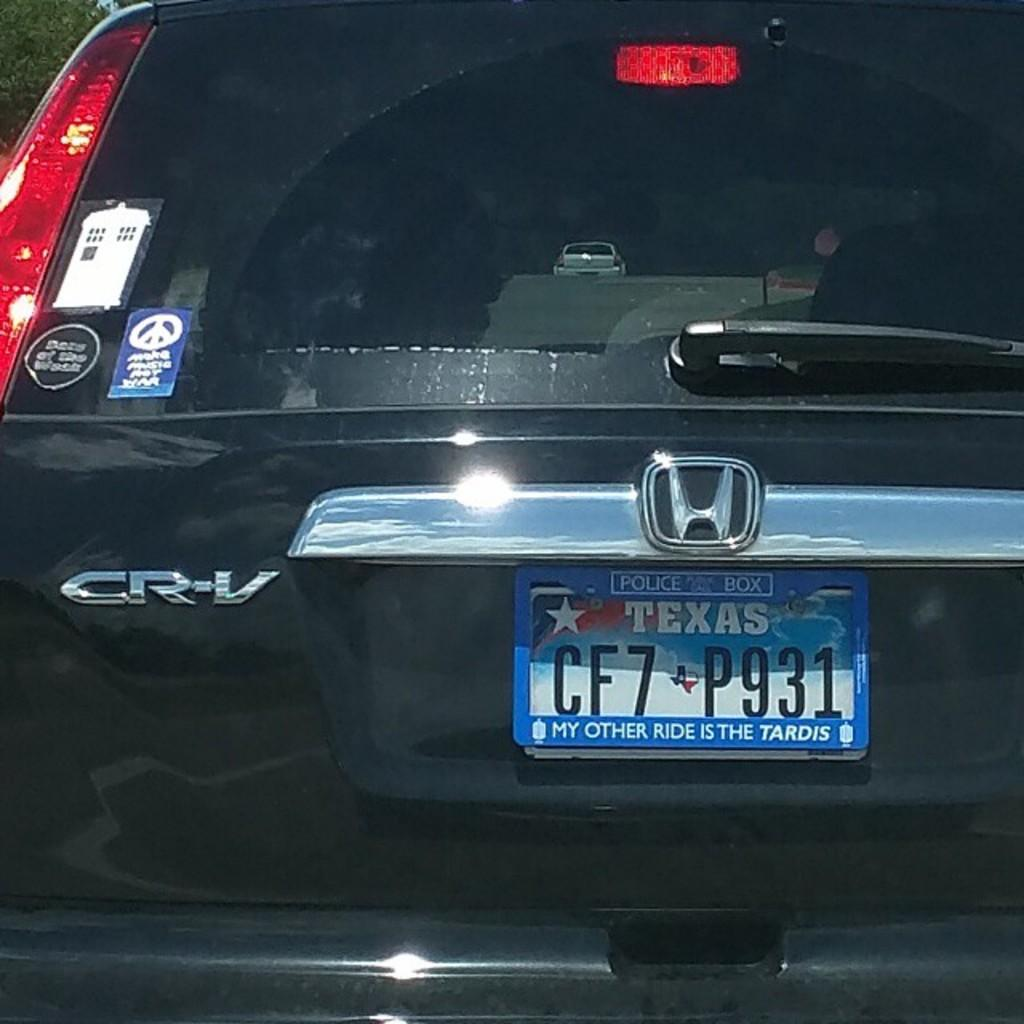Provide a one-sentence caption for the provided image. A Texas license plate says "my other ride is the Tardis.". 